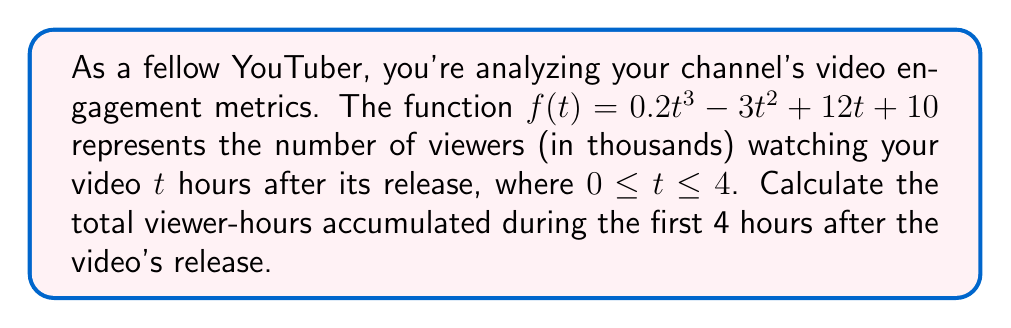Solve this math problem. To find the total viewer-hours, we need to calculate the area under the curve of $f(t)$ from $t=0$ to $t=4$. This can be done using a definite integral.

Step 1: Set up the definite integral
$$\int_0^4 f(t) dt = \int_0^4 (0.2t^3 - 3t^2 + 12t + 10) dt$$

Step 2: Integrate the function
$$\int (0.2t^3 - 3t^2 + 12t + 10) dt = 0.05t^4 - t^3 + 6t^2 + 10t + C$$

Step 3: Apply the limits of integration
$$\left[0.05t^4 - t^3 + 6t^2 + 10t\right]_0^4$$

Step 4: Calculate the difference
$$(0.05(4^4) - 4^3 + 6(4^2) + 10(4)) - (0.05(0^4) - 0^3 + 6(0^2) + 10(0))$$
$$= (51.2 - 64 + 96 + 40) - 0 = 123.2$$

Step 5: Interpret the result
The area under the curve represents 123.2 thousand viewer-hours.
Answer: 123,200 viewer-hours 